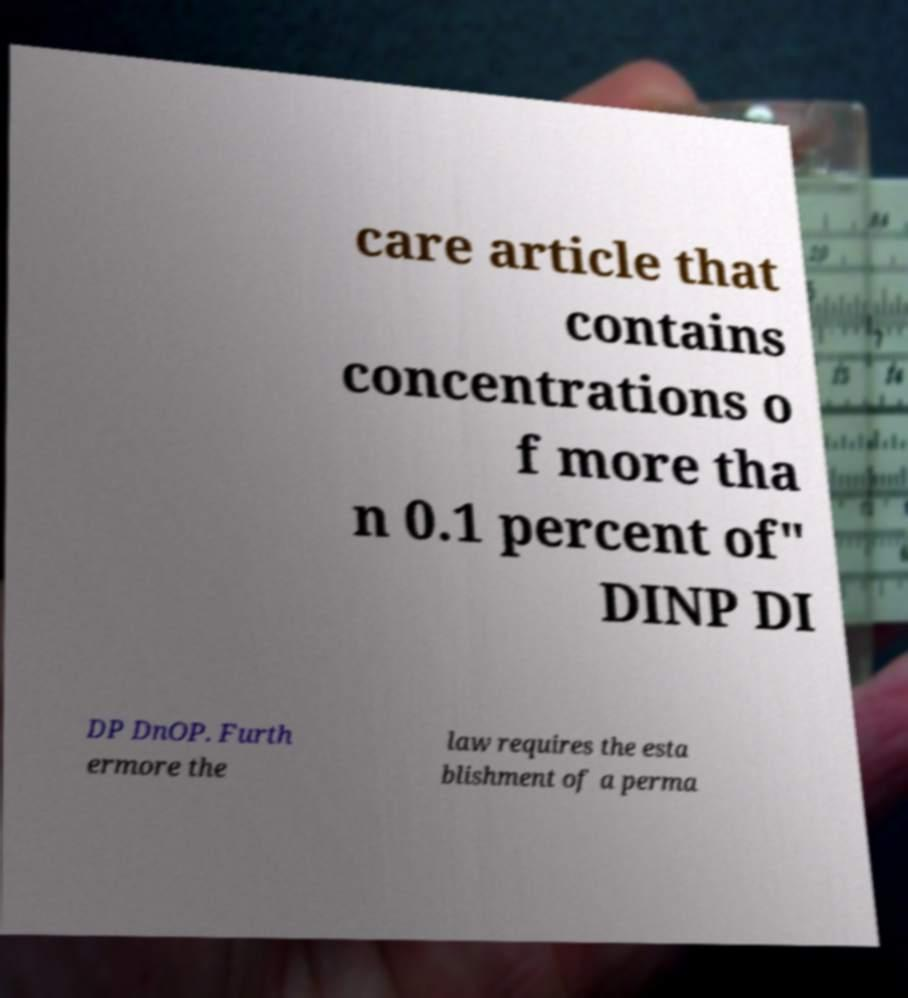Could you assist in decoding the text presented in this image and type it out clearly? care article that contains concentrations o f more tha n 0.1 percent of" DINP DI DP DnOP. Furth ermore the law requires the esta blishment of a perma 